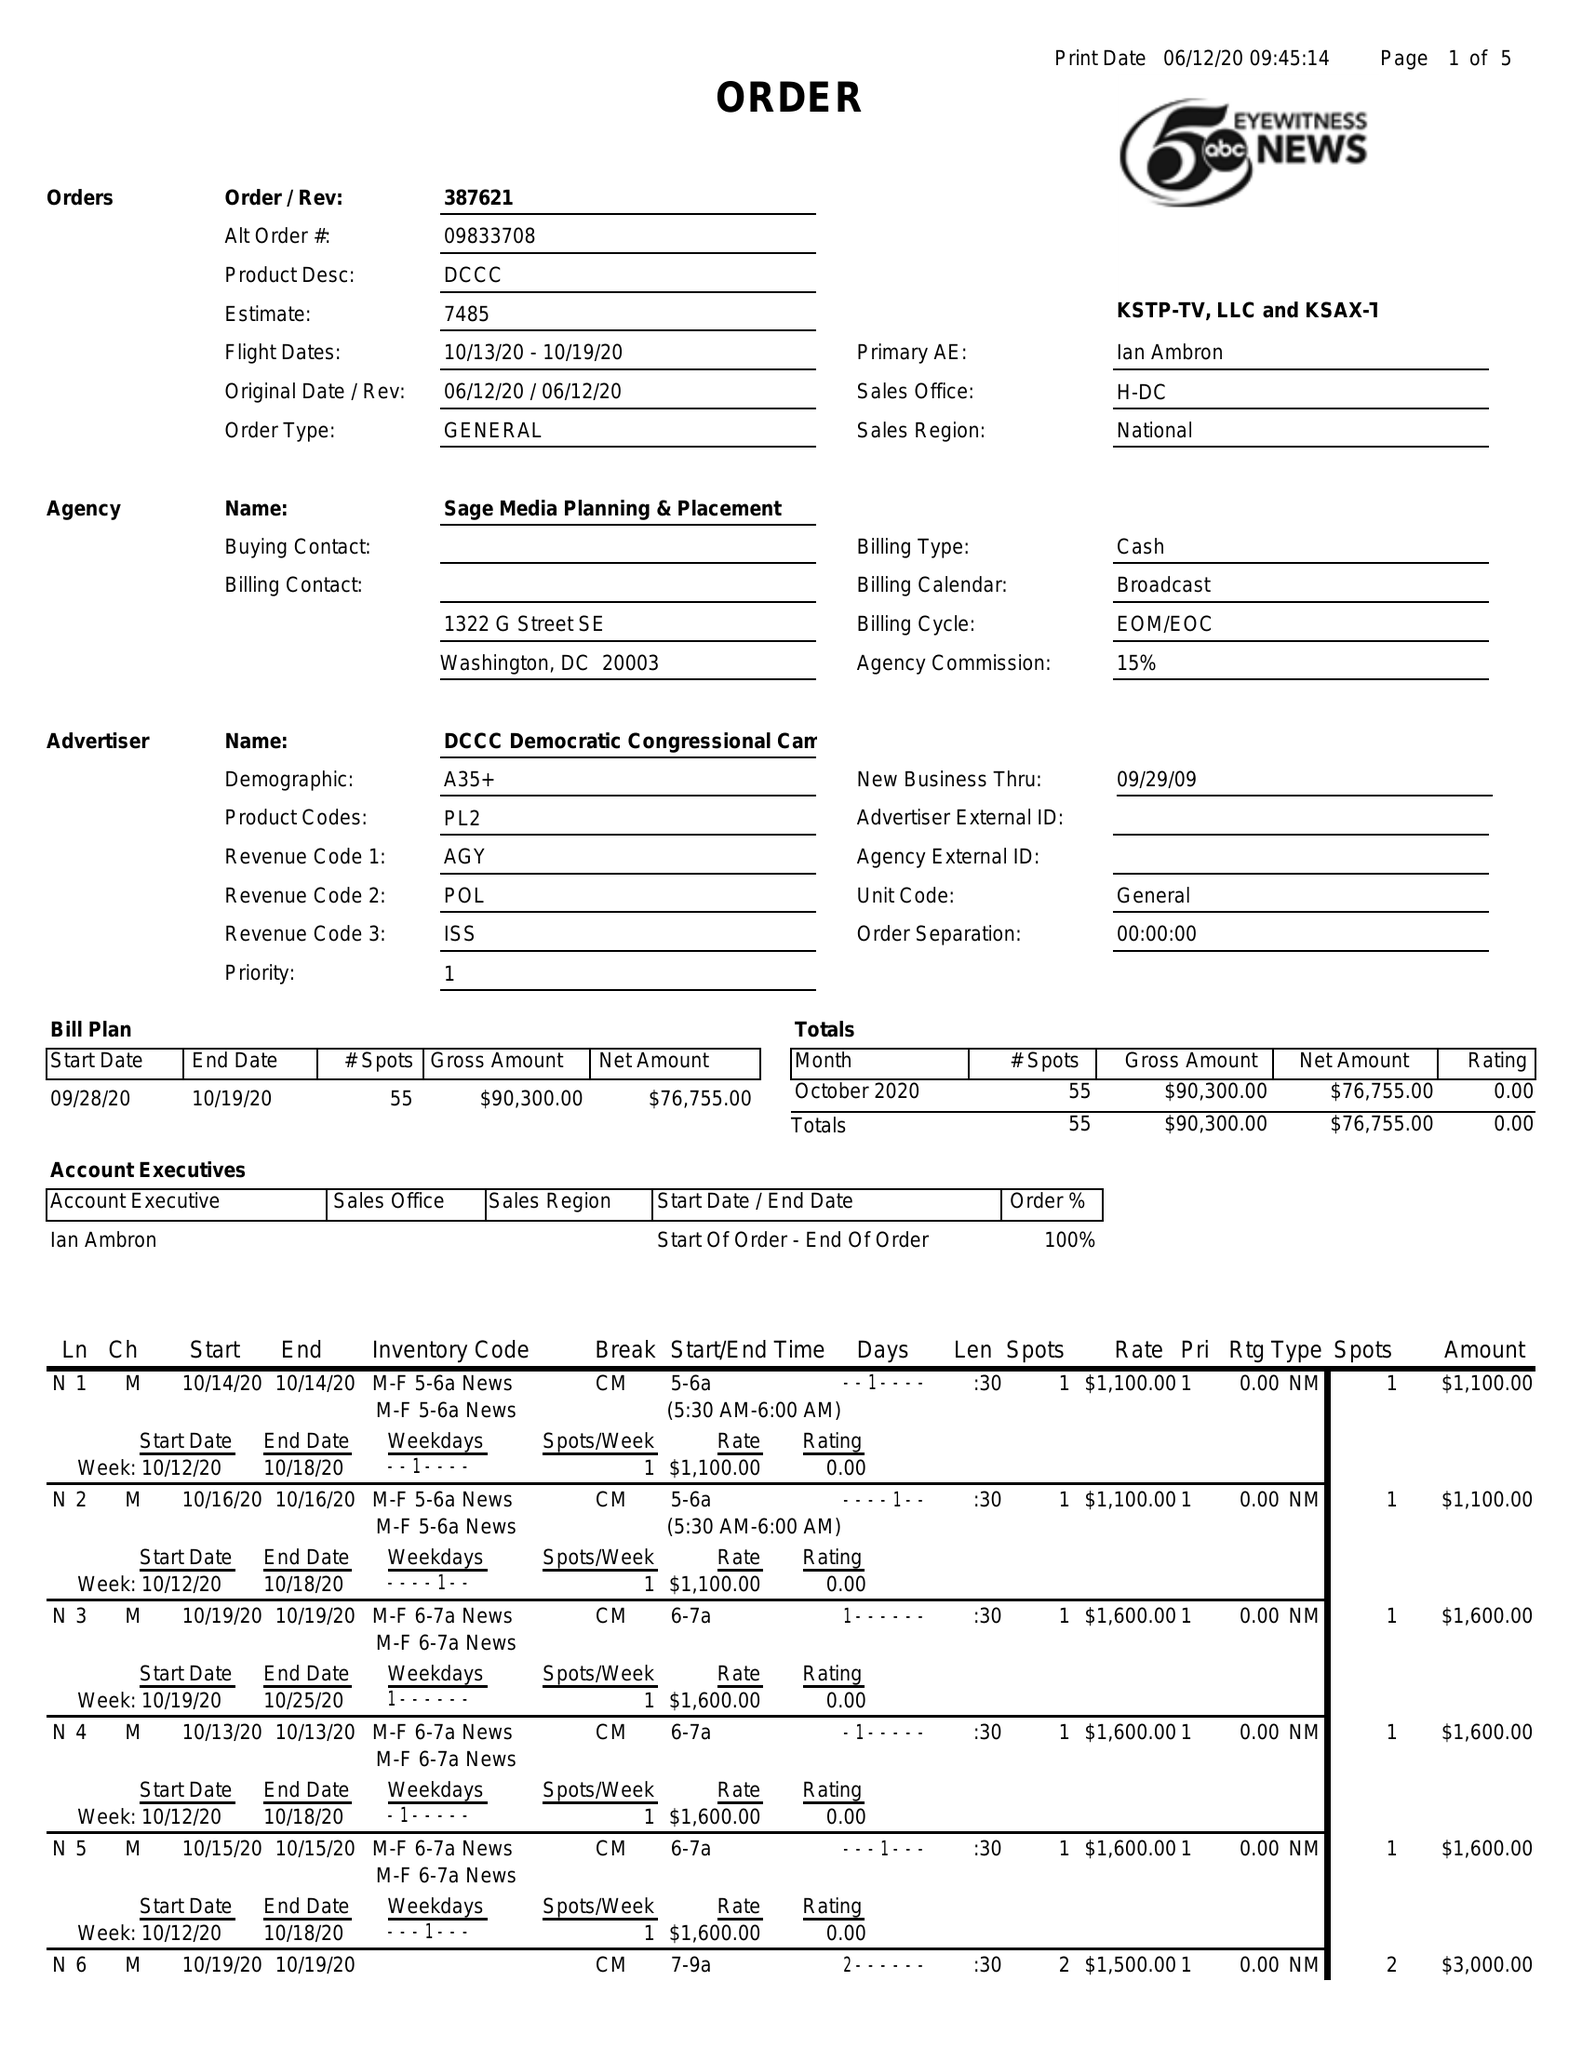What is the value for the advertiser?
Answer the question using a single word or phrase. DCCC DEMOCRATIC CONGRESSIONAL CAMPAIGN COMMITTEE 